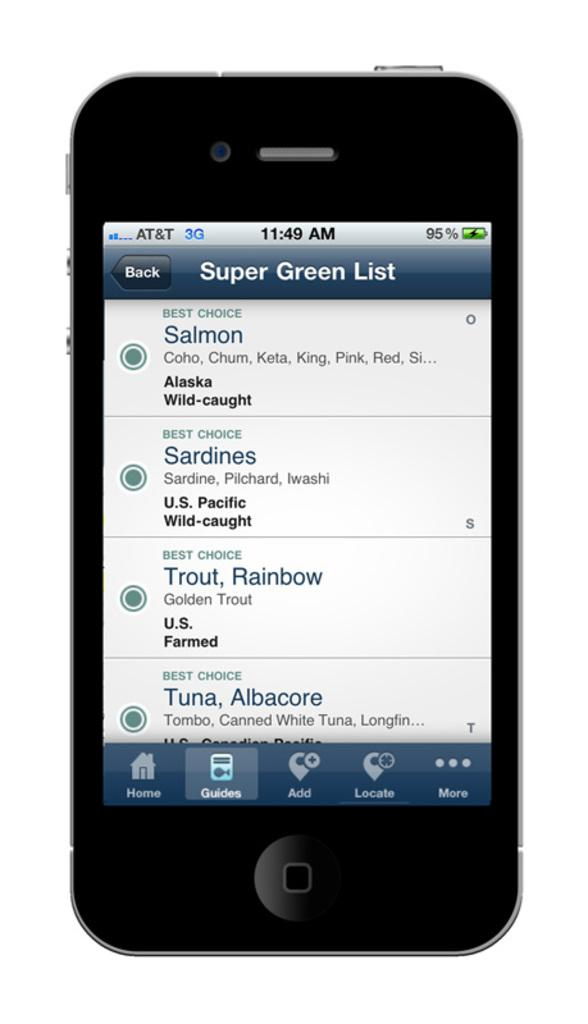<image>
Provide a brief description of the given image. A mobile phone has a list of responsibly harvested fish on its home screen. 